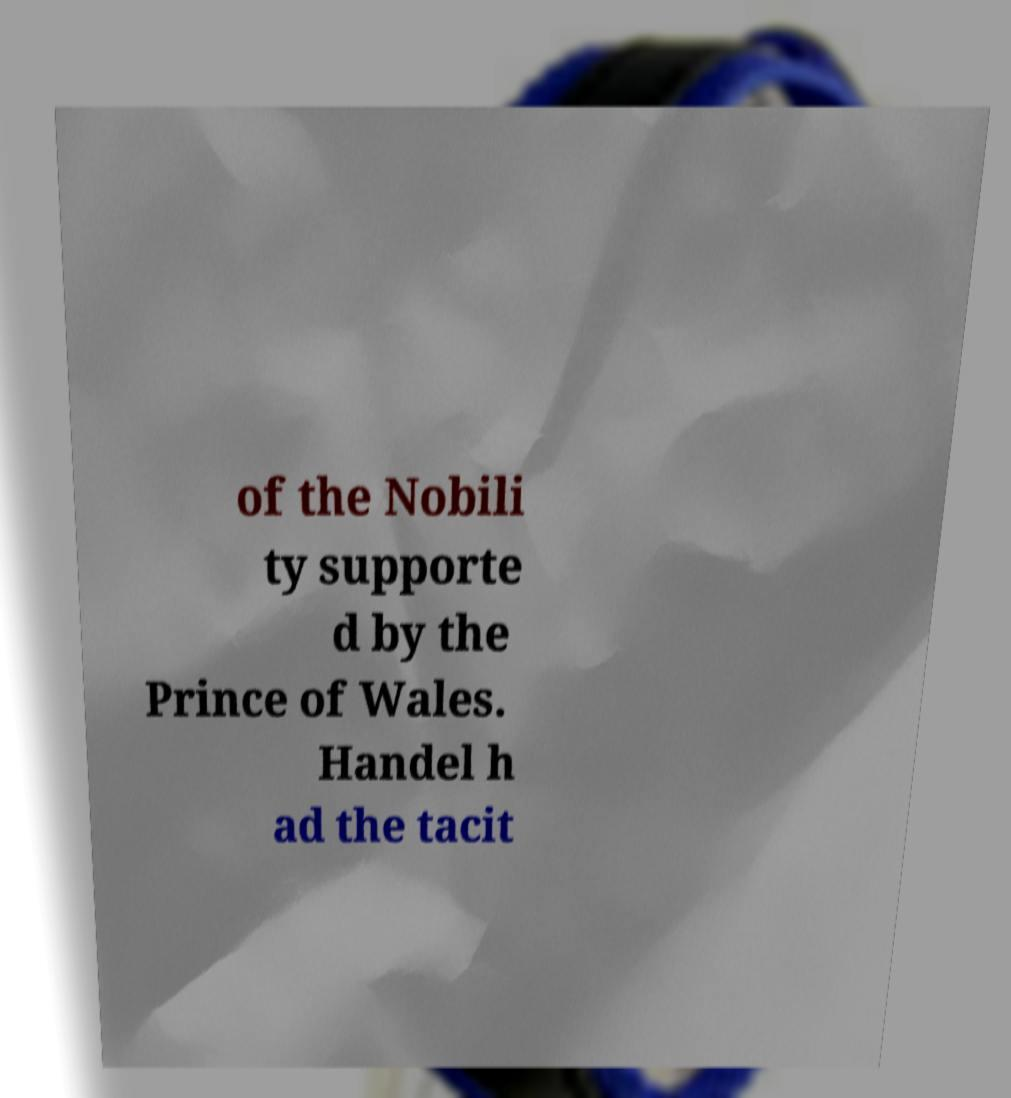Please identify and transcribe the text found in this image. of the Nobili ty supporte d by the Prince of Wales. Handel h ad the tacit 